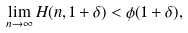Convert formula to latex. <formula><loc_0><loc_0><loc_500><loc_500>\lim _ { n \to \infty } H ( n , 1 + \delta ) < \phi ( 1 + \delta ) ,</formula> 